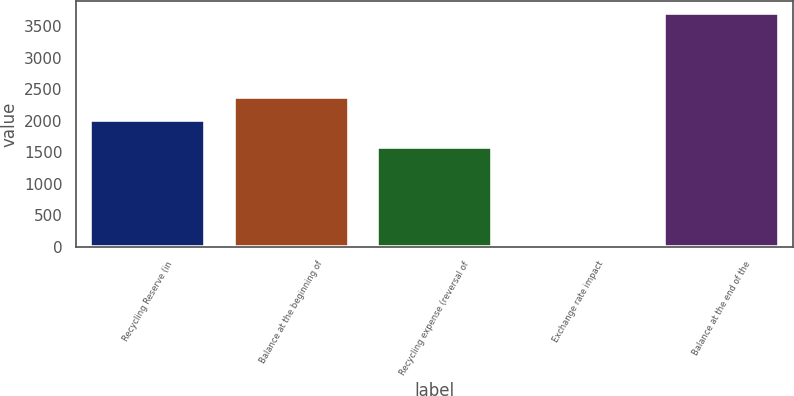<chart> <loc_0><loc_0><loc_500><loc_500><bar_chart><fcel>Recycling Reserve (in<fcel>Balance at the beginning of<fcel>Recycling expense (reversal of<fcel>Exchange rate impact<fcel>Balance at the end of the<nl><fcel>2007<fcel>2376.5<fcel>1580<fcel>11<fcel>3706<nl></chart> 